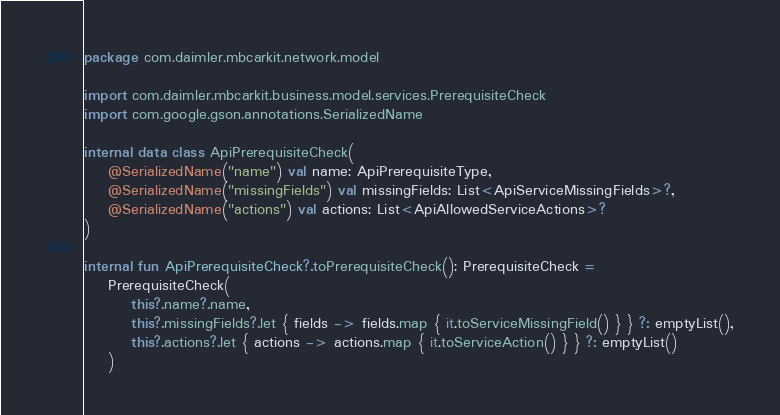<code> <loc_0><loc_0><loc_500><loc_500><_Kotlin_>package com.daimler.mbcarkit.network.model

import com.daimler.mbcarkit.business.model.services.PrerequisiteCheck
import com.google.gson.annotations.SerializedName

internal data class ApiPrerequisiteCheck(
    @SerializedName("name") val name: ApiPrerequisiteType,
    @SerializedName("missingFields") val missingFields: List<ApiServiceMissingFields>?,
    @SerializedName("actions") val actions: List<ApiAllowedServiceActions>?
)

internal fun ApiPrerequisiteCheck?.toPrerequisiteCheck(): PrerequisiteCheck =
    PrerequisiteCheck(
        this?.name?.name,
        this?.missingFields?.let { fields -> fields.map { it.toServiceMissingField() } } ?: emptyList(),
        this?.actions?.let { actions -> actions.map { it.toServiceAction() } } ?: emptyList()
    )
</code> 